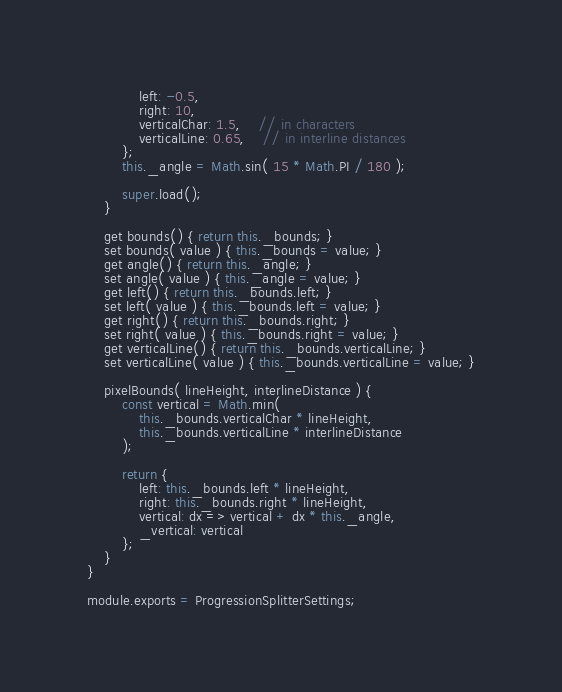Convert code to text. <code><loc_0><loc_0><loc_500><loc_500><_JavaScript_>			left: -0.5,
			right: 10,
			verticalChar: 1.5,	// in characters
			verticalLine: 0.65,	// in interline distances
		};
		this._angle = Math.sin( 15 * Math.PI / 180 );

		super.load();
	}

	get bounds() { return this._bounds; }
	set bounds( value ) { this._bounds = value; }
	get angle() { return this._angle; }
	set angle( value ) { this._angle = value; }
	get left() { return this._bounds.left; }
	set left( value ) { this._bounds.left = value; }
	get right() { return this._bounds.right; }
	set right( value ) { this._bounds.right = value; }
	get verticalLine() { return this._bounds.verticalLine; }
	set verticalLine( value ) { this._bounds.verticalLine = value; }

	pixelBounds( lineHeight, interlineDistance ) {
		const vertical = Math.min(
			this._bounds.verticalChar * lineHeight,
			this._bounds.verticalLine * interlineDistance
		);

		return {
			left: this._bounds.left * lineHeight,
			right: this._bounds.right * lineHeight,
			vertical: dx => vertical + dx * this._angle,
			_vertical: vertical
		};
	}
}

module.exports = ProgressionSplitterSettings;</code> 